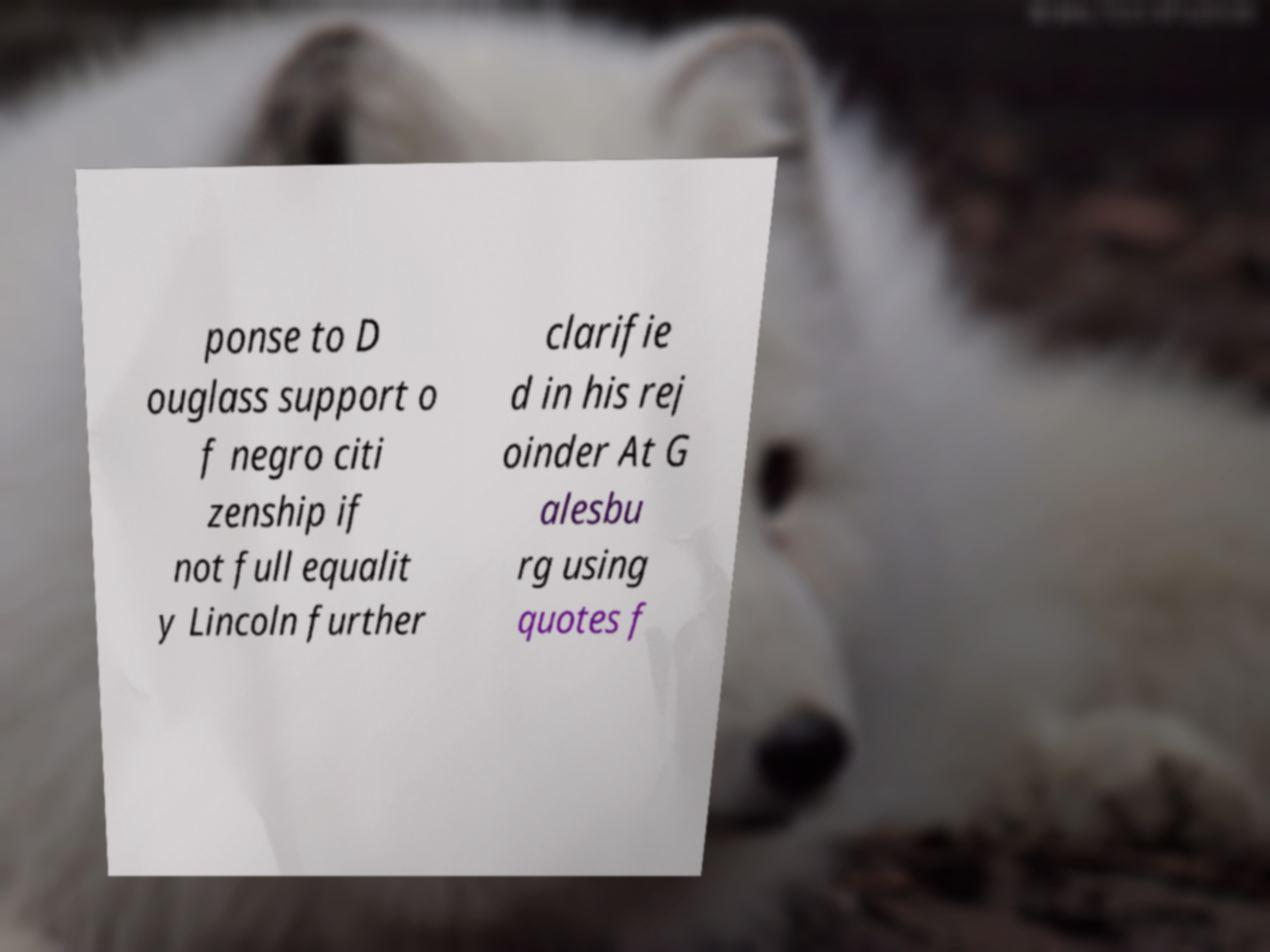Could you extract and type out the text from this image? ponse to D ouglass support o f negro citi zenship if not full equalit y Lincoln further clarifie d in his rej oinder At G alesbu rg using quotes f 